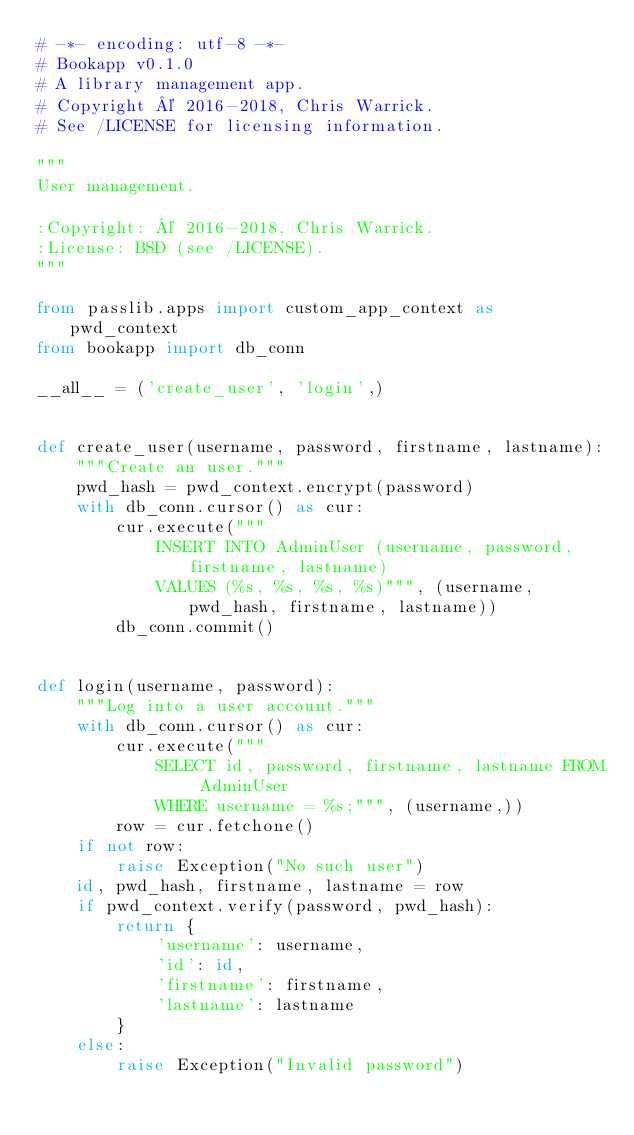Convert code to text. <code><loc_0><loc_0><loc_500><loc_500><_Python_># -*- encoding: utf-8 -*-
# Bookapp v0.1.0
# A library management app.
# Copyright © 2016-2018, Chris Warrick.
# See /LICENSE for licensing information.

"""
User management.

:Copyright: © 2016-2018, Chris Warrick.
:License: BSD (see /LICENSE).
"""

from passlib.apps import custom_app_context as pwd_context
from bookapp import db_conn

__all__ = ('create_user', 'login',)


def create_user(username, password, firstname, lastname):
    """Create an user."""
    pwd_hash = pwd_context.encrypt(password)
    with db_conn.cursor() as cur:
        cur.execute("""
            INSERT INTO AdminUser (username, password, firstname, lastname)
            VALUES (%s, %s, %s, %s)""", (username, pwd_hash, firstname, lastname))
        db_conn.commit()


def login(username, password):
    """Log into a user account."""
    with db_conn.cursor() as cur:
        cur.execute("""
            SELECT id, password, firstname, lastname FROM AdminUser
            WHERE username = %s;""", (username,))
        row = cur.fetchone()
    if not row:
        raise Exception("No such user")
    id, pwd_hash, firstname, lastname = row
    if pwd_context.verify(password, pwd_hash):
        return {
            'username': username,
            'id': id,
            'firstname': firstname,
            'lastname': lastname
        }
    else:
        raise Exception("Invalid password")
</code> 